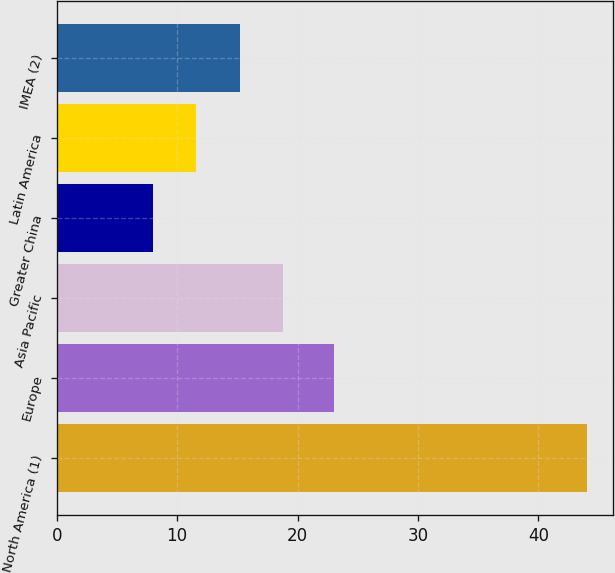Convert chart to OTSL. <chart><loc_0><loc_0><loc_500><loc_500><bar_chart><fcel>North America (1)<fcel>Europe<fcel>Asia Pacific<fcel>Greater China<fcel>Latin America<fcel>IMEA (2)<nl><fcel>44<fcel>23<fcel>18.8<fcel>8<fcel>11.6<fcel>15.2<nl></chart> 